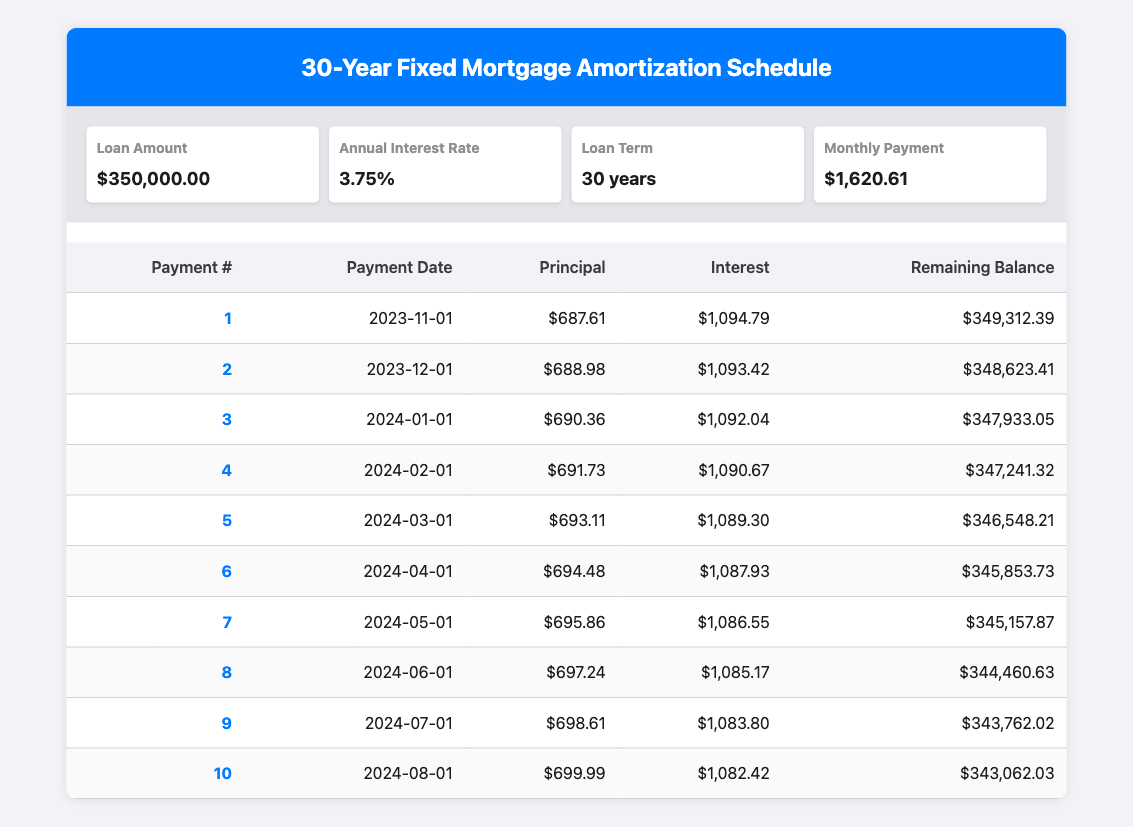What is the remaining balance after the first payment? The first payment number is 1, and the remaining balance listed in the table for this payment is 349,312.39.
Answer: 349,312.39 How much total interest is paid in the first three months? To find the total interest paid in the first three months, we add the interest payments from rows 1, 2, and 3: 1,094.79 + 1,093.42 + 1,092.04 = 3,280.25.
Answer: 3,280.25 Is the principal payment for the second month greater than the principal payment for the first month? The principal payment for the second month is 688.98, while the first month is 687.61. Since 688.98 is greater than 687.61, the answer is yes.
Answer: Yes What is the average principal payment for the first ten months? The total principal payments for the first ten payments need to be calculated: 687.61 + 688.98 + 690.36 + 691.73 + 693.11 + 694.48 + 695.86 + 697.24 + 698.61 + 699.99 = 6,108.77. Dividing this by 10 gives us an average principal payment of 610.88.
Answer: 610.88 What is the total mortgage payment after 30 years? The monthly payment is 1,620.61, and there are 360 total payments (30 years at 12 months each). The total payment is calculated by multiplying these values: 1,620.61 * 360 = 583,819.60.
Answer: 583,819.60 How much interest is paid in the eighth month? The table shows the interest payment for the eighth month as 1,085.17, which is a direct reference from the corresponding row.
Answer: 1,085.17 What is the difference between the principal payments of the first and fourth months? The principal payment for the first month is 687.61, and for the fourth month, it is 691.73. To find the difference: 691.73 - 687.61 = 4.12.
Answer: 4.12 In which month does the remaining balance first drop below 345,500? By inspecting the remaining balances, we observe that in the sixth month, the balance is 345,853.73, and in the seventh month, it drops to 345,157.87, which is below 345,500. Therefore, this occurs in the seventh month.
Answer: Seventh month 